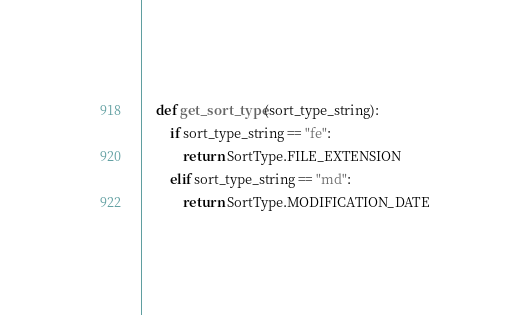<code> <loc_0><loc_0><loc_500><loc_500><_Python_>    def get_sort_type(sort_type_string):
        if sort_type_string == "fe":
            return SortType.FILE_EXTENSION
        elif sort_type_string == "md":
            return SortType.MODIFICATION_DATE
</code> 